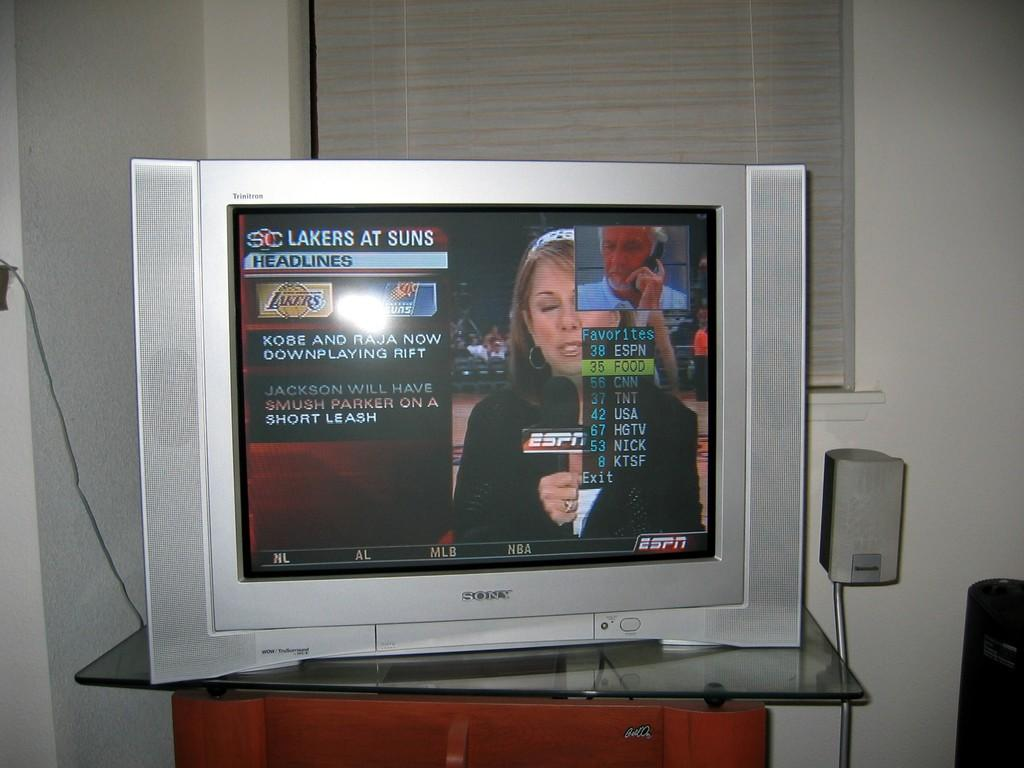<image>
Share a concise interpretation of the image provided. A silver TV that says Sony is showing a sports game and says Lakers at Suns. 